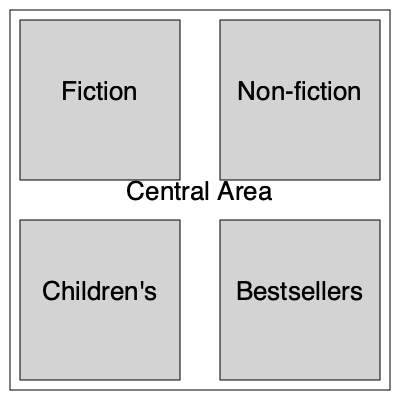In the given bookstore layout, which section is strategically placed to maximize exposure for potentially classified stories turned into bestsellers? To determine the best location for showcasing classified stories turned into bestsellers, we need to consider the following factors:

1. Visibility: The section should be easily visible to customers entering the store.
2. Traffic flow: It should be in an area with high foot traffic.
3. Prominence: The section should be in a prominent position to attract attention.

Analyzing the layout:

1. The Fiction and Non-fiction sections are at the front of the store, which typically receive high traffic but may not be ideal for specialized bestsellers.
2. The Children's section is less suitable for adult-oriented classified stories.
3. The Bestsellers section is strategically placed in the bottom right corner, which is:
   a) Visible from the entrance
   b) Likely to be passed by customers browsing other sections
   c) In a prominent position that suggests importance

4. The central area could be used for displays or promotions but is not a dedicated section.

Given that classified stories turned into bestsellers would likely be high-profile books, the Bestsellers section is the most strategic location for maximizing their exposure and sales potential.
Answer: Bestsellers section 